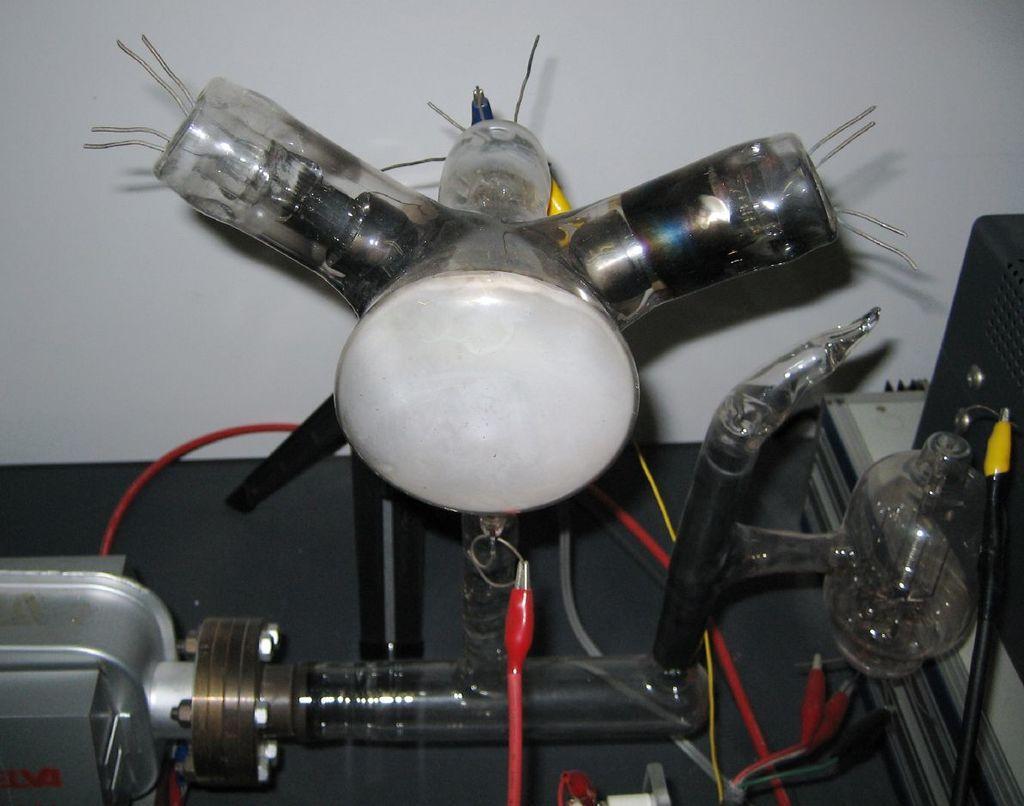In one or two sentences, can you explain what this image depicts? In this picture, we see some electrical equipment and a bulb are placed on the black table. On the right side, we see a black color object which looks like a box are placed on the table. In the background, we see a white wall. 